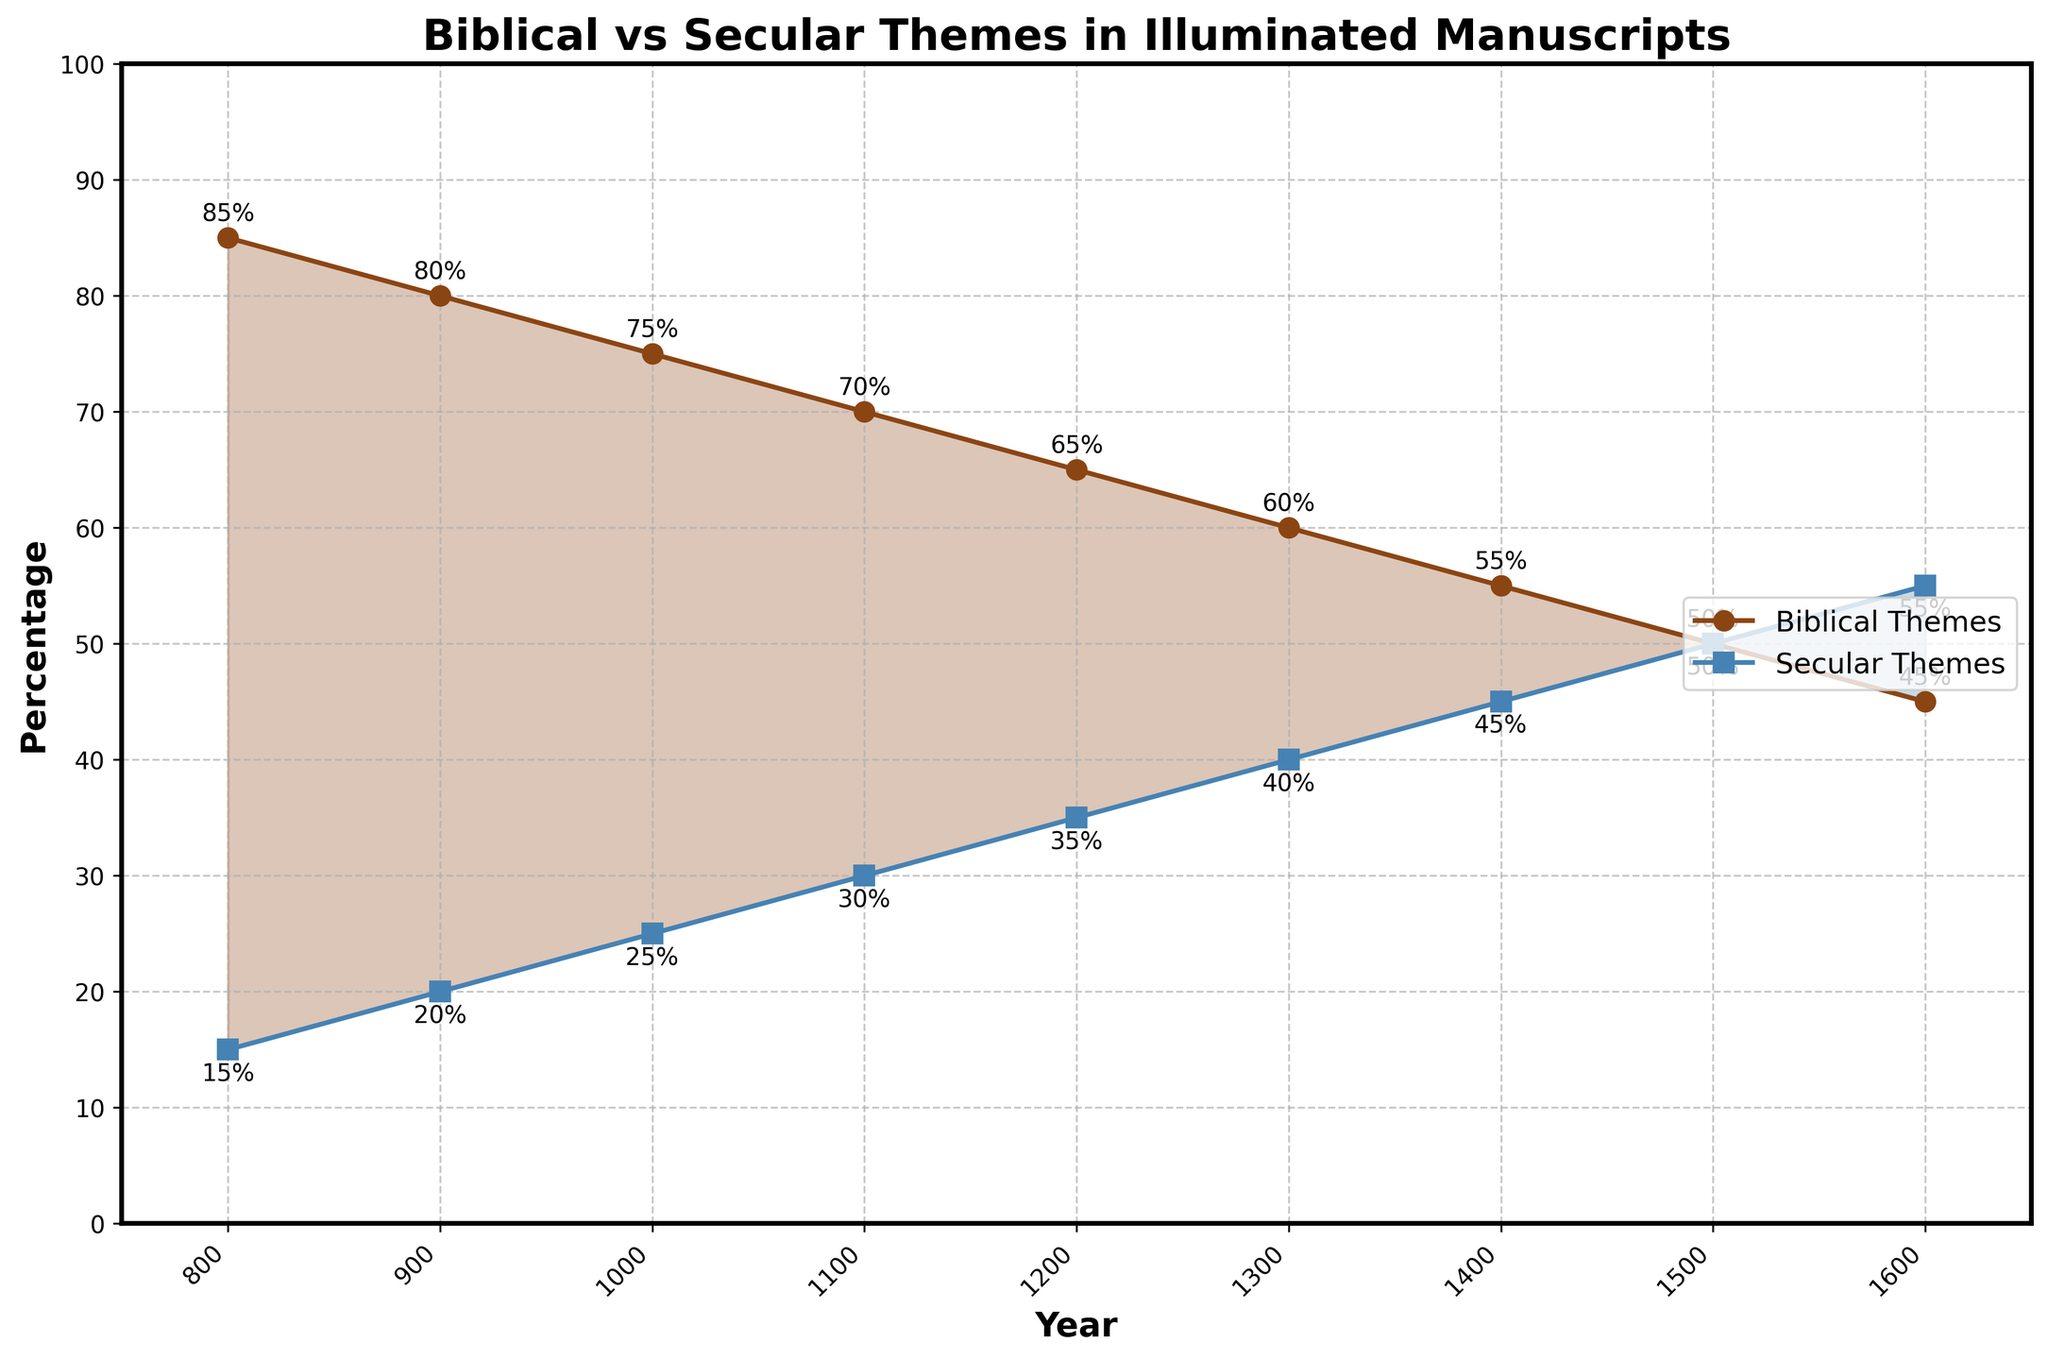What trend can you observe for Biblical themes from 800 to 1600? From 800 to 1600, there is a clear downward trend in the percentage of Biblical themes, decreasing steadily from 85% in 800 to 45% in 1600. Each subsequent century shows a notable decline.
Answer: Downward trend In which century did secular themes surpass biblical themes? By examining the graph, secular themes surpass biblical themes between the years 1500 and 1600. At 1500, both themes are equal at 50%, and by 1600, secular themes are at 55% while biblical themes are at 45%.
Answer: Between 1500 and 1600 What is the difference in the percentage of biblical themes between the years 800 and 1200? In 800, the percentage for biblical themes is 85%, and in 1200 it is 65%. The difference is calculated as 85% - 65% = 20%.
Answer: 20% In which year did both themes hold the same percentage, and what was that percentage? Around the year 1500, both biblical and secular themes are at 50%. The graph shows lines intersecting at this point.
Answer: 1500, 50% How much did secular themes increase from 900 to 1400? In 900, secular themes were at 20%, and by 1400, they increased to 45%. The increase is calculated as 45% - 20% = 25%.
Answer: 25% What were the percentages of biblical and secular themes in the year 1300? In the year 1300, the graph shows biblical themes at 60% and secular themes at 40%.
Answer: Biblical: 60%, Secular: 40% Describe the general trend for secular themes over the entire period shown in the graph. Over the period from 800 to 1600, secular themes show an upward trend. Starting at 15% in 800, they increase steadily and surpass biblical themes by reaching 55% in 1600.
Answer: Upward trend Between which two consecutive centuries did biblical themes experience the steepest decline? The steepest decline in biblical themes occurs between 800 and 900, with a decrease from 85% to 80%. Despite being the initial smallest value, it represents a relatively sharp decline.
Answer: 800 to 900 What is the sum of the percentage of biblical themes in the years 800, 1000, and 1400? The percentages of biblical themes in 800, 1000, and 1400 are 85%, 75%, and 55% respectively. Summing these values: 85 + 75 + 55 = 215.
Answer: 215 How does the percentage of secular themes in 1600 compare to that in 800? In 800, secular themes are at 15%, while in 1600, they are at 55%. Secular themes in 1600 are significantly higher compared to 800.
Answer: Significantly higher in 1600 